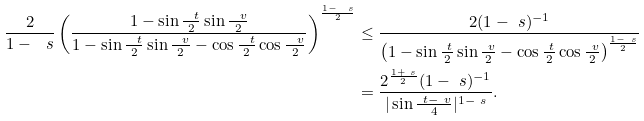<formula> <loc_0><loc_0><loc_500><loc_500>\frac { 2 } { 1 - \ s } \left ( \frac { 1 - \sin \frac { \ t } { 2 } \sin \frac { \ v } { 2 } } { 1 - \sin \frac { \ t } { 2 } \sin \frac { \ v } { 2 } - \cos \frac { \ t } { 2 } \cos \frac { \ v } { 2 } } \right ) ^ { \frac { 1 - \ s } { 2 } } & \leq \frac { 2 ( 1 - \ s ) ^ { - 1 } } { \left ( 1 - \sin \frac { \ t } { 2 } \sin \frac { \ v } { 2 } - \cos \frac { \ t } { 2 } \cos \frac { \ v } { 2 } \right ) ^ { \frac { 1 - \ s } { 2 } } } \\ & = \frac { 2 ^ { \frac { 1 + \ s } { 2 } } ( 1 - \ s ) ^ { - 1 } } { | \sin \frac { \ t - \ v } { 4 } | ^ { 1 - \ s } } .</formula> 